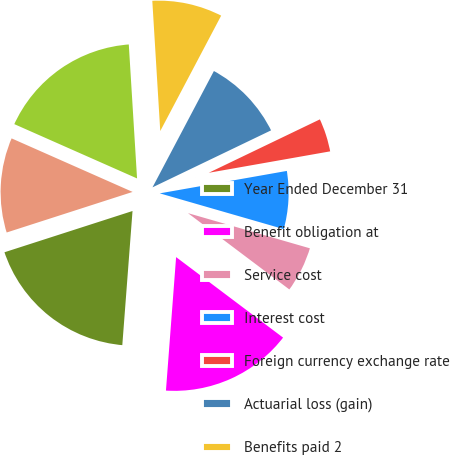Convert chart. <chart><loc_0><loc_0><loc_500><loc_500><pie_chart><fcel>Year Ended December 31<fcel>Benefit obligation at<fcel>Service cost<fcel>Interest cost<fcel>Foreign currency exchange rate<fcel>Actuarial loss (gain)<fcel>Benefits paid 2<fcel>Other<fcel>Benefit obligation at end of<fcel>Fair value of plan assets at<nl><fcel>18.83%<fcel>15.94%<fcel>5.8%<fcel>7.25%<fcel>4.35%<fcel>10.14%<fcel>8.7%<fcel>0.01%<fcel>17.39%<fcel>11.59%<nl></chart> 